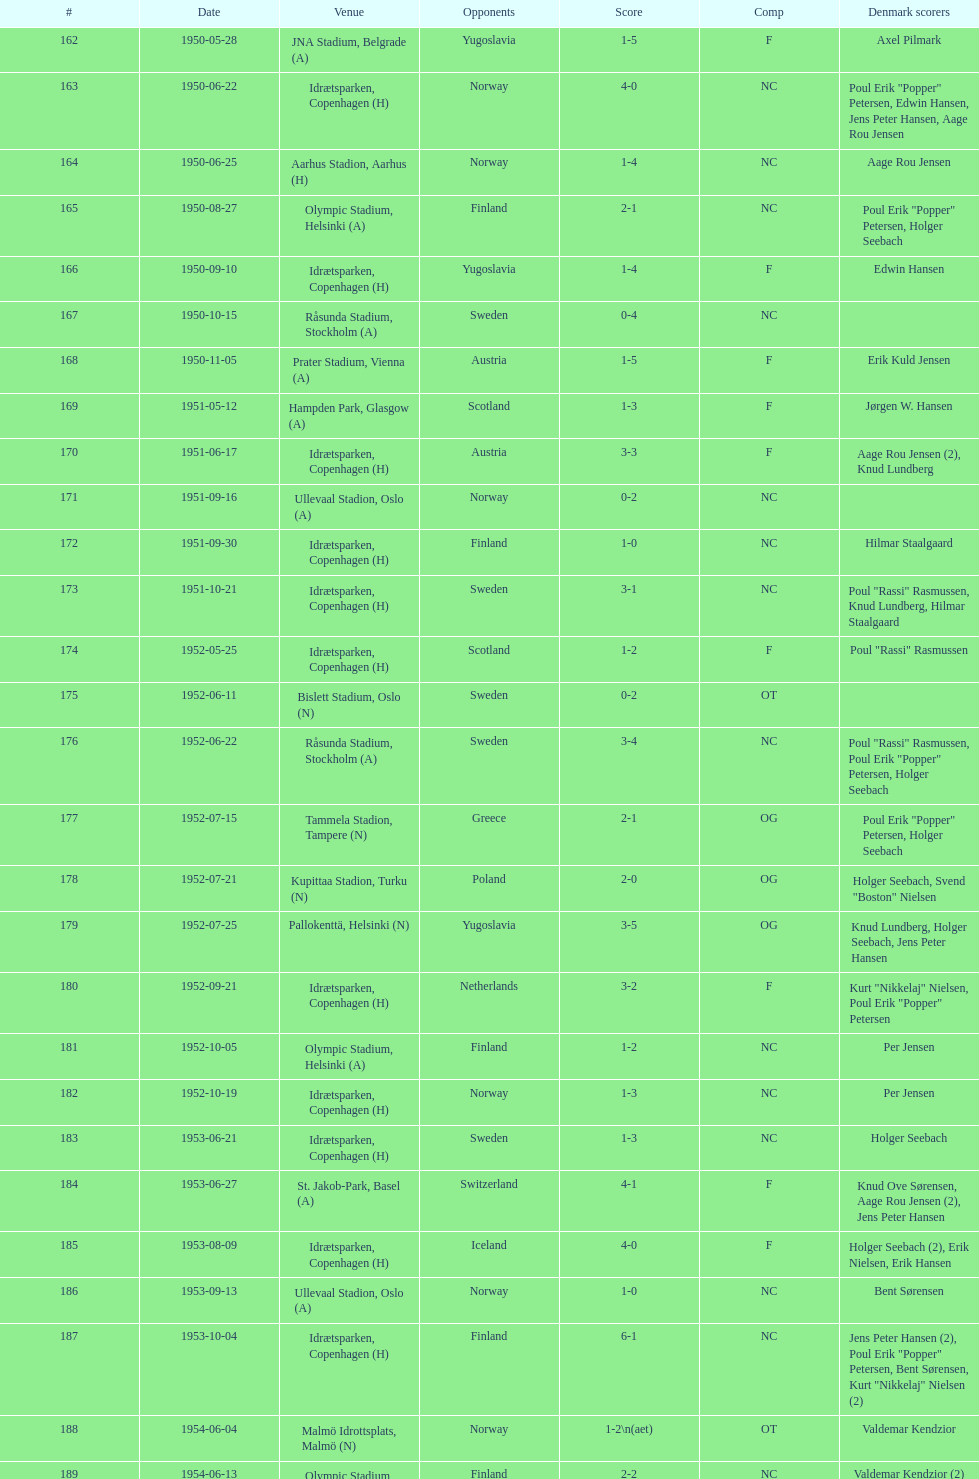Give me the full table as a dictionary. {'header': ['#', 'Date', 'Venue', 'Opponents', 'Score', 'Comp', 'Denmark scorers'], 'rows': [['162', '1950-05-28', 'JNA Stadium, Belgrade (A)', 'Yugoslavia', '1-5', 'F', 'Axel Pilmark'], ['163', '1950-06-22', 'Idrætsparken, Copenhagen (H)', 'Norway', '4-0', 'NC', 'Poul Erik "Popper" Petersen, Edwin Hansen, Jens Peter Hansen, Aage Rou Jensen'], ['164', '1950-06-25', 'Aarhus Stadion, Aarhus (H)', 'Norway', '1-4', 'NC', 'Aage Rou Jensen'], ['165', '1950-08-27', 'Olympic Stadium, Helsinki (A)', 'Finland', '2-1', 'NC', 'Poul Erik "Popper" Petersen, Holger Seebach'], ['166', '1950-09-10', 'Idrætsparken, Copenhagen (H)', 'Yugoslavia', '1-4', 'F', 'Edwin Hansen'], ['167', '1950-10-15', 'Råsunda Stadium, Stockholm (A)', 'Sweden', '0-4', 'NC', ''], ['168', '1950-11-05', 'Prater Stadium, Vienna (A)', 'Austria', '1-5', 'F', 'Erik Kuld Jensen'], ['169', '1951-05-12', 'Hampden Park, Glasgow (A)', 'Scotland', '1-3', 'F', 'Jørgen W. Hansen'], ['170', '1951-06-17', 'Idrætsparken, Copenhagen (H)', 'Austria', '3-3', 'F', 'Aage Rou Jensen (2), Knud Lundberg'], ['171', '1951-09-16', 'Ullevaal Stadion, Oslo (A)', 'Norway', '0-2', 'NC', ''], ['172', '1951-09-30', 'Idrætsparken, Copenhagen (H)', 'Finland', '1-0', 'NC', 'Hilmar Staalgaard'], ['173', '1951-10-21', 'Idrætsparken, Copenhagen (H)', 'Sweden', '3-1', 'NC', 'Poul "Rassi" Rasmussen, Knud Lundberg, Hilmar Staalgaard'], ['174', '1952-05-25', 'Idrætsparken, Copenhagen (H)', 'Scotland', '1-2', 'F', 'Poul "Rassi" Rasmussen'], ['175', '1952-06-11', 'Bislett Stadium, Oslo (N)', 'Sweden', '0-2', 'OT', ''], ['176', '1952-06-22', 'Råsunda Stadium, Stockholm (A)', 'Sweden', '3-4', 'NC', 'Poul "Rassi" Rasmussen, Poul Erik "Popper" Petersen, Holger Seebach'], ['177', '1952-07-15', 'Tammela Stadion, Tampere (N)', 'Greece', '2-1', 'OG', 'Poul Erik "Popper" Petersen, Holger Seebach'], ['178', '1952-07-21', 'Kupittaa Stadion, Turku (N)', 'Poland', '2-0', 'OG', 'Holger Seebach, Svend "Boston" Nielsen'], ['179', '1952-07-25', 'Pallokenttä, Helsinki (N)', 'Yugoslavia', '3-5', 'OG', 'Knud Lundberg, Holger Seebach, Jens Peter Hansen'], ['180', '1952-09-21', 'Idrætsparken, Copenhagen (H)', 'Netherlands', '3-2', 'F', 'Kurt "Nikkelaj" Nielsen, Poul Erik "Popper" Petersen'], ['181', '1952-10-05', 'Olympic Stadium, Helsinki (A)', 'Finland', '1-2', 'NC', 'Per Jensen'], ['182', '1952-10-19', 'Idrætsparken, Copenhagen (H)', 'Norway', '1-3', 'NC', 'Per Jensen'], ['183', '1953-06-21', 'Idrætsparken, Copenhagen (H)', 'Sweden', '1-3', 'NC', 'Holger Seebach'], ['184', '1953-06-27', 'St. Jakob-Park, Basel (A)', 'Switzerland', '4-1', 'F', 'Knud Ove Sørensen, Aage Rou Jensen (2), Jens Peter Hansen'], ['185', '1953-08-09', 'Idrætsparken, Copenhagen (H)', 'Iceland', '4-0', 'F', 'Holger Seebach (2), Erik Nielsen, Erik Hansen'], ['186', '1953-09-13', 'Ullevaal Stadion, Oslo (A)', 'Norway', '1-0', 'NC', 'Bent Sørensen'], ['187', '1953-10-04', 'Idrætsparken, Copenhagen (H)', 'Finland', '6-1', 'NC', 'Jens Peter Hansen (2), Poul Erik "Popper" Petersen, Bent Sørensen, Kurt "Nikkelaj" Nielsen (2)'], ['188', '1954-06-04', 'Malmö Idrottsplats, Malmö (N)', 'Norway', '1-2\\n(aet)', 'OT', 'Valdemar Kendzior'], ['189', '1954-06-13', 'Olympic Stadium, Helsinki (A)', 'Finland', '2-2', 'NC', 'Valdemar Kendzior (2)'], ['190', '1954-09-19', 'Idrætsparken, Copenhagen (H)', 'Switzerland', '1-1', 'F', 'Jørgen Olesen'], ['191', '1954-10-10', 'Råsunda Stadium, Stockholm (A)', 'Sweden', '2-5', 'NC', 'Jens Peter Hansen, Bent Sørensen'], ['192', '1954-10-31', 'Idrætsparken, Copenhagen (H)', 'Norway', '0-1', 'NC', ''], ['193', '1955-03-13', 'Olympic Stadium, Amsterdam (A)', 'Netherlands', '1-1', 'F', 'Vagn Birkeland'], ['194', '1955-05-15', 'Idrætsparken, Copenhagen (H)', 'Hungary', '0-6', 'F', ''], ['195', '1955-06-19', 'Idrætsparken, Copenhagen (H)', 'Finland', '2-1', 'NC', 'Jens Peter Hansen (2)'], ['196', '1955-06-03', 'Melavollur, Reykjavík (A)', 'Iceland', '4-0', 'F', 'Aage Rou Jensen, Jens Peter Hansen, Poul Pedersen (2)'], ['197', '1955-09-11', 'Ullevaal Stadion, Oslo (A)', 'Norway', '1-1', 'NC', 'Jørgen Jacobsen'], ['198', '1955-10-02', 'Idrætsparken, Copenhagen (H)', 'England', '1-5', 'NC', 'Knud Lundberg'], ['199', '1955-10-16', 'Idrætsparken, Copenhagen (H)', 'Sweden', '3-3', 'NC', 'Ove Andersen (2), Knud Lundberg'], ['200', '1956-05-23', 'Dynamo Stadium, Moscow (A)', 'USSR', '1-5', 'F', 'Knud Lundberg'], ['201', '1956-06-24', 'Idrætsparken, Copenhagen (H)', 'Norway', '2-3', 'NC', 'Knud Lundberg, Poul Pedersen'], ['202', '1956-07-01', 'Idrætsparken, Copenhagen (H)', 'USSR', '2-5', 'F', 'Ove Andersen, Aage Rou Jensen'], ['203', '1956-09-16', 'Olympic Stadium, Helsinki (A)', 'Finland', '4-0', 'NC', 'Poul Pedersen, Jørgen Hansen, Ove Andersen (2)'], ['204', '1956-10-03', 'Dalymount Park, Dublin (A)', 'Republic of Ireland', '1-2', 'WCQ', 'Aage Rou Jensen'], ['205', '1956-10-21', 'Råsunda Stadium, Stockholm (A)', 'Sweden', '1-1', 'NC', 'Jens Peter Hansen'], ['206', '1956-11-04', 'Idrætsparken, Copenhagen (H)', 'Netherlands', '2-2', 'F', 'Jørgen Olesen, Knud Lundberg'], ['207', '1956-12-05', 'Molineux, Wolverhampton (A)', 'England', '2-5', 'WCQ', 'Ove Bech Nielsen (2)'], ['208', '1957-05-15', 'Idrætsparken, Copenhagen (H)', 'England', '1-4', 'WCQ', 'John Jensen'], ['209', '1957-05-26', 'Idrætsparken, Copenhagen (H)', 'Bulgaria', '1-1', 'F', 'Aage Rou Jensen'], ['210', '1957-06-18', 'Olympic Stadium, Helsinki (A)', 'Finland', '0-2', 'OT', ''], ['211', '1957-06-19', 'Tammela Stadion, Tampere (N)', 'Norway', '2-0', 'OT', 'Egon Jensen, Jørgen Hansen'], ['212', '1957-06-30', 'Idrætsparken, Copenhagen (H)', 'Sweden', '1-2', 'NC', 'Jens Peter Hansen'], ['213', '1957-07-10', 'Laugardalsvöllur, Reykjavík (A)', 'Iceland', '6-2', 'OT', 'Egon Jensen (3), Poul Pedersen, Jens Peter Hansen (2)'], ['214', '1957-09-22', 'Ullevaal Stadion, Oslo (A)', 'Norway', '2-2', 'NC', 'Poul Pedersen, Peder Kjær'], ['215', '1957-10-02', 'Idrætsparken, Copenhagen (H)', 'Republic of Ireland', '0-2', 'WCQ', ''], ['216', '1957-10-13', 'Idrætsparken, Copenhagen (H)', 'Finland', '3-0', 'NC', 'Finn Alfred Hansen, Ove Bech Nielsen, Mogens Machon'], ['217', '1958-05-15', 'Aarhus Stadion, Aarhus (H)', 'Curaçao', '3-2', 'F', 'Poul Pedersen, Henning Enoksen (2)'], ['218', '1958-05-25', 'Idrætsparken, Copenhagen (H)', 'Poland', '3-2', 'F', 'Jørn Sørensen, Poul Pedersen (2)'], ['219', '1958-06-29', 'Idrætsparken, Copenhagen (H)', 'Norway', '1-2', 'NC', 'Poul Pedersen'], ['220', '1958-09-14', 'Olympic Stadium, Helsinki (A)', 'Finland', '4-1', 'NC', 'Poul Pedersen, Mogens Machon, John Danielsen (2)'], ['221', '1958-09-24', 'Idrætsparken, Copenhagen (H)', 'West Germany', '1-1', 'F', 'Henning Enoksen'], ['222', '1958-10-15', 'Idrætsparken, Copenhagen (H)', 'Netherlands', '1-5', 'F', 'Henning Enoksen'], ['223', '1958-10-26', 'Råsunda Stadium, Stockholm (A)', 'Sweden', '4-4', 'NC', 'Ole Madsen (2), Henning Enoksen, Jørn Sørensen'], ['224', '1959-06-21', 'Idrætsparken, Copenhagen (H)', 'Sweden', '0-6', 'NC', ''], ['225', '1959-06-26', 'Laugardalsvöllur, Reykjavík (A)', 'Iceland', '4-2', 'OGQ', 'Jens Peter Hansen (2), Ole Madsen (2)'], ['226', '1959-07-02', 'Idrætsparken, Copenhagen (H)', 'Norway', '2-1', 'OGQ', 'Henning Enoksen, Ole Madsen'], ['227', '1959-08-18', 'Idrætsparken, Copenhagen (H)', 'Iceland', '1-1', 'OGQ', 'Henning Enoksen'], ['228', '1959-09-13', 'Ullevaal Stadion, Oslo (A)', 'Norway', '4-2', 'OGQ\\nNC', 'Harald Nielsen, Henning Enoksen (2), Poul Pedersen'], ['229', '1959-09-23', 'Idrætsparken, Copenhagen (H)', 'Czechoslovakia', '2-2', 'ENQ', 'Poul Pedersen, Bent Hansen'], ['230', '1959-10-04', 'Idrætsparken, Copenhagen (H)', 'Finland', '4-0', 'NC', 'Harald Nielsen (3), John Kramer'], ['231', '1959-10-18', 'Stadion Za Lužánkami, Brno (A)', 'Czechoslovakia', '1-5', 'ENQ', 'John Kramer'], ['232', '1959-12-02', 'Olympic Stadium, Athens (A)', 'Greece', '3-1', 'F', 'Henning Enoksen (2), Poul Pedersen'], ['233', '1959-12-06', 'Vasil Levski National Stadium, Sofia (A)', 'Bulgaria', '1-2', 'F', 'Henning Enoksen']]} What was the name of the venue mentioned prior to olympic stadium on august 27, 1950? Aarhus Stadion, Aarhus. 